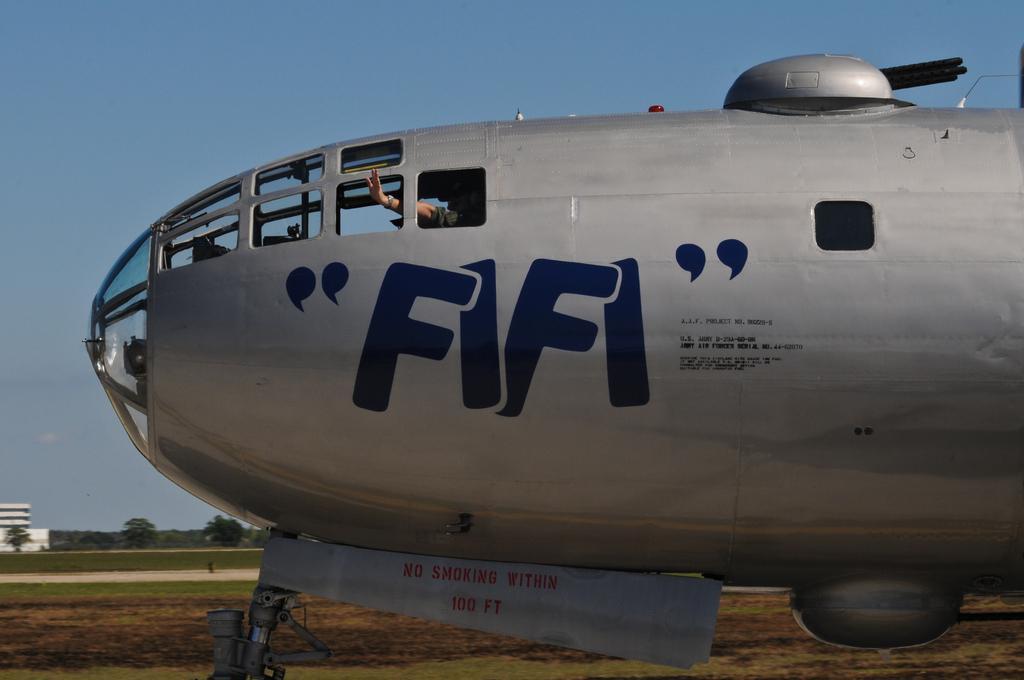Can you describe this image briefly? In this picture I can observe an airplane. This airline is in grey color. I can observe blue color text on this airplane. In the background there are trees, building and a sky. 